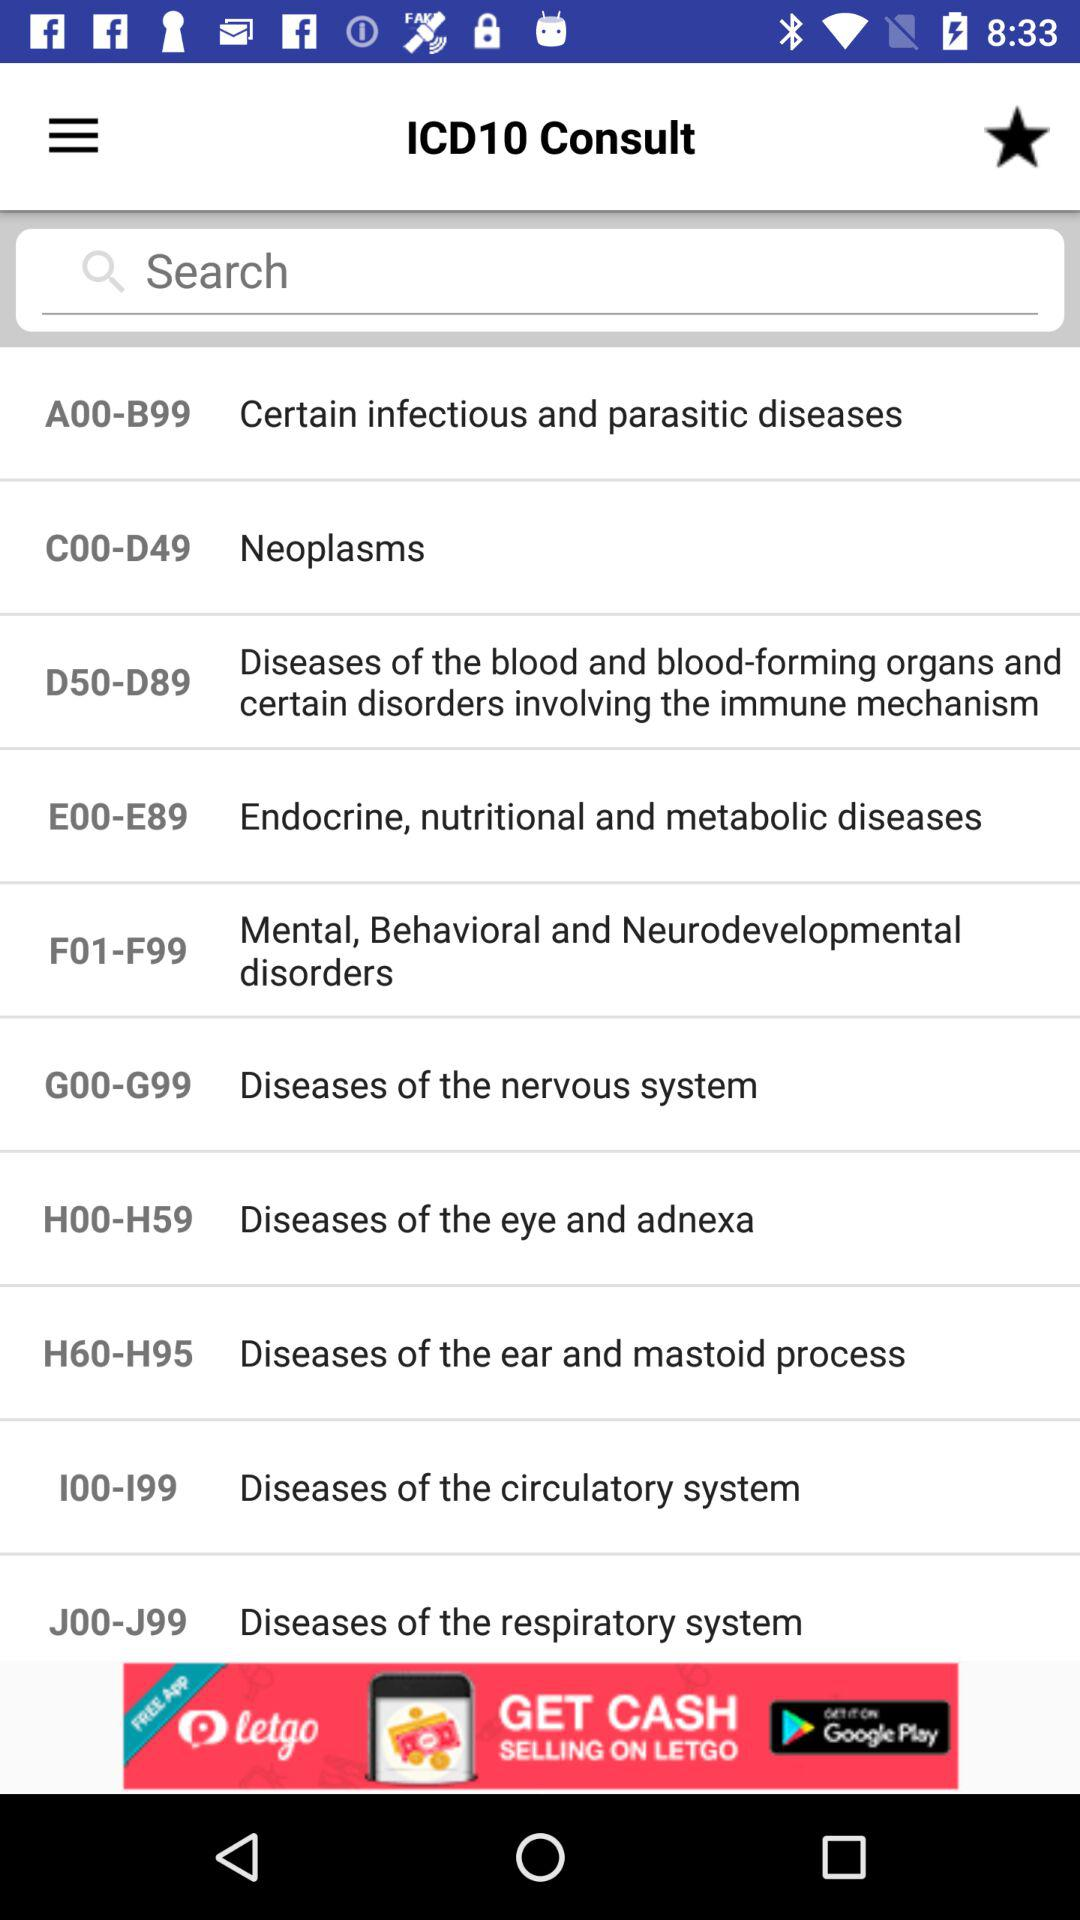I00-I99 is the "ICD" code for which diseases? It is for "Diseases of the circulatory system". 